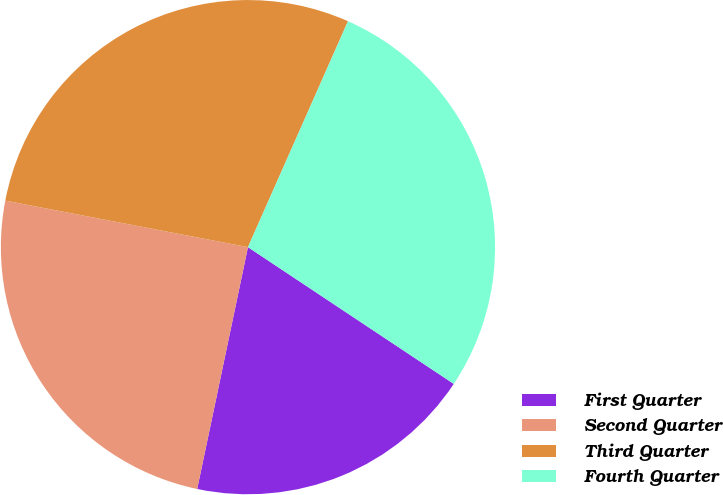Convert chart to OTSL. <chart><loc_0><loc_0><loc_500><loc_500><pie_chart><fcel>First Quarter<fcel>Second Quarter<fcel>Third Quarter<fcel>Fourth Quarter<nl><fcel>18.96%<fcel>24.72%<fcel>28.62%<fcel>27.7%<nl></chart> 